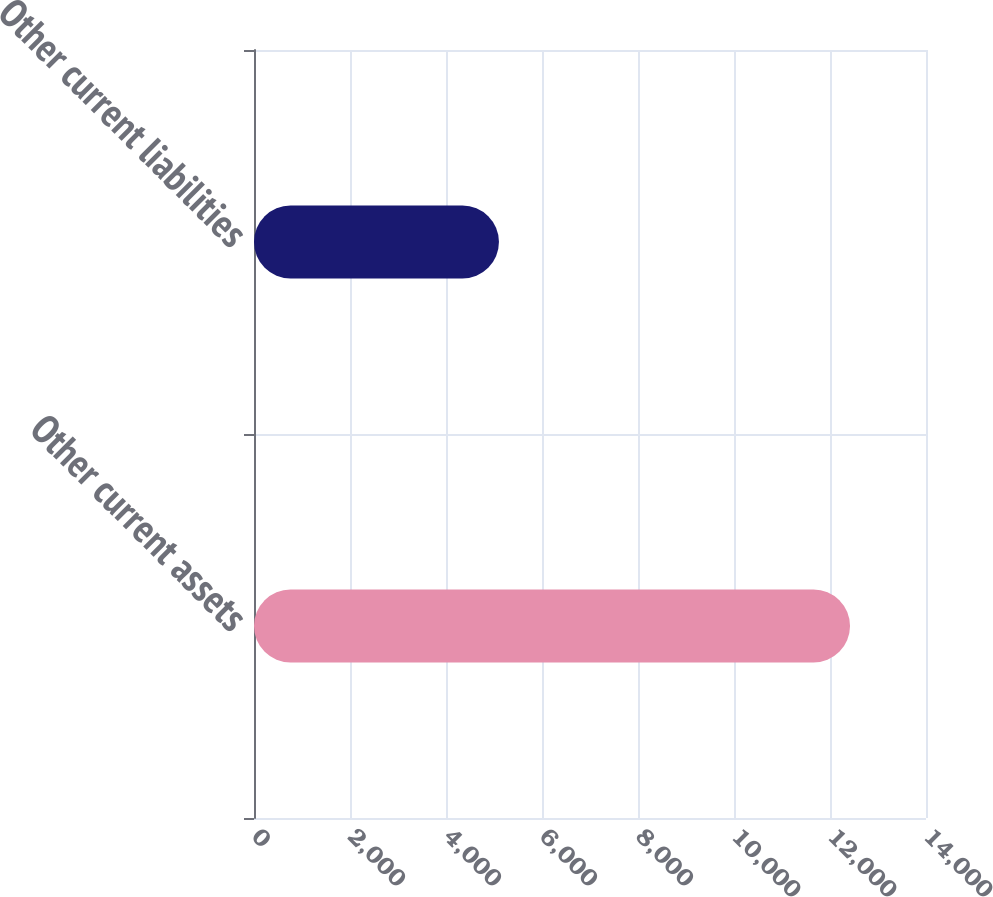Convert chart. <chart><loc_0><loc_0><loc_500><loc_500><bar_chart><fcel>Other current assets<fcel>Other current liabilities<nl><fcel>12417<fcel>5103<nl></chart> 